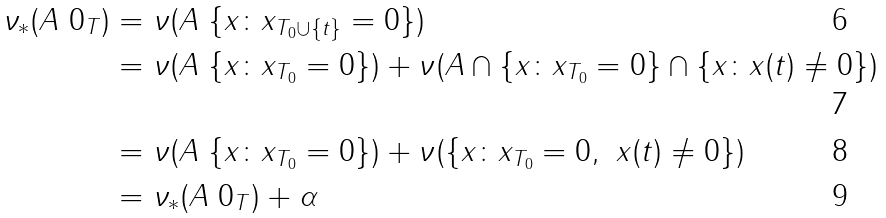Convert formula to latex. <formula><loc_0><loc_0><loc_500><loc_500>\nu _ { \ast } ( A \ 0 _ { T } ) & = \nu ( A \ \{ x \colon x _ { T _ { 0 } \cup \{ t \} } = 0 \} ) \\ & = \nu ( A \ \{ x \colon x _ { T _ { 0 } } = 0 \} ) + \nu ( A \cap \{ x \colon x _ { T _ { 0 } } = 0 \} \cap \{ x \colon x ( t ) \ne 0 \} ) \\ & = \nu ( A \ \{ x \colon x _ { T _ { 0 } } = 0 \} ) + \nu ( \{ x \colon x _ { T _ { 0 } } = 0 , \ x ( t ) \ne 0 \} ) \\ & = \nu _ { \ast } ( A \ 0 _ { T } ) + \alpha</formula> 